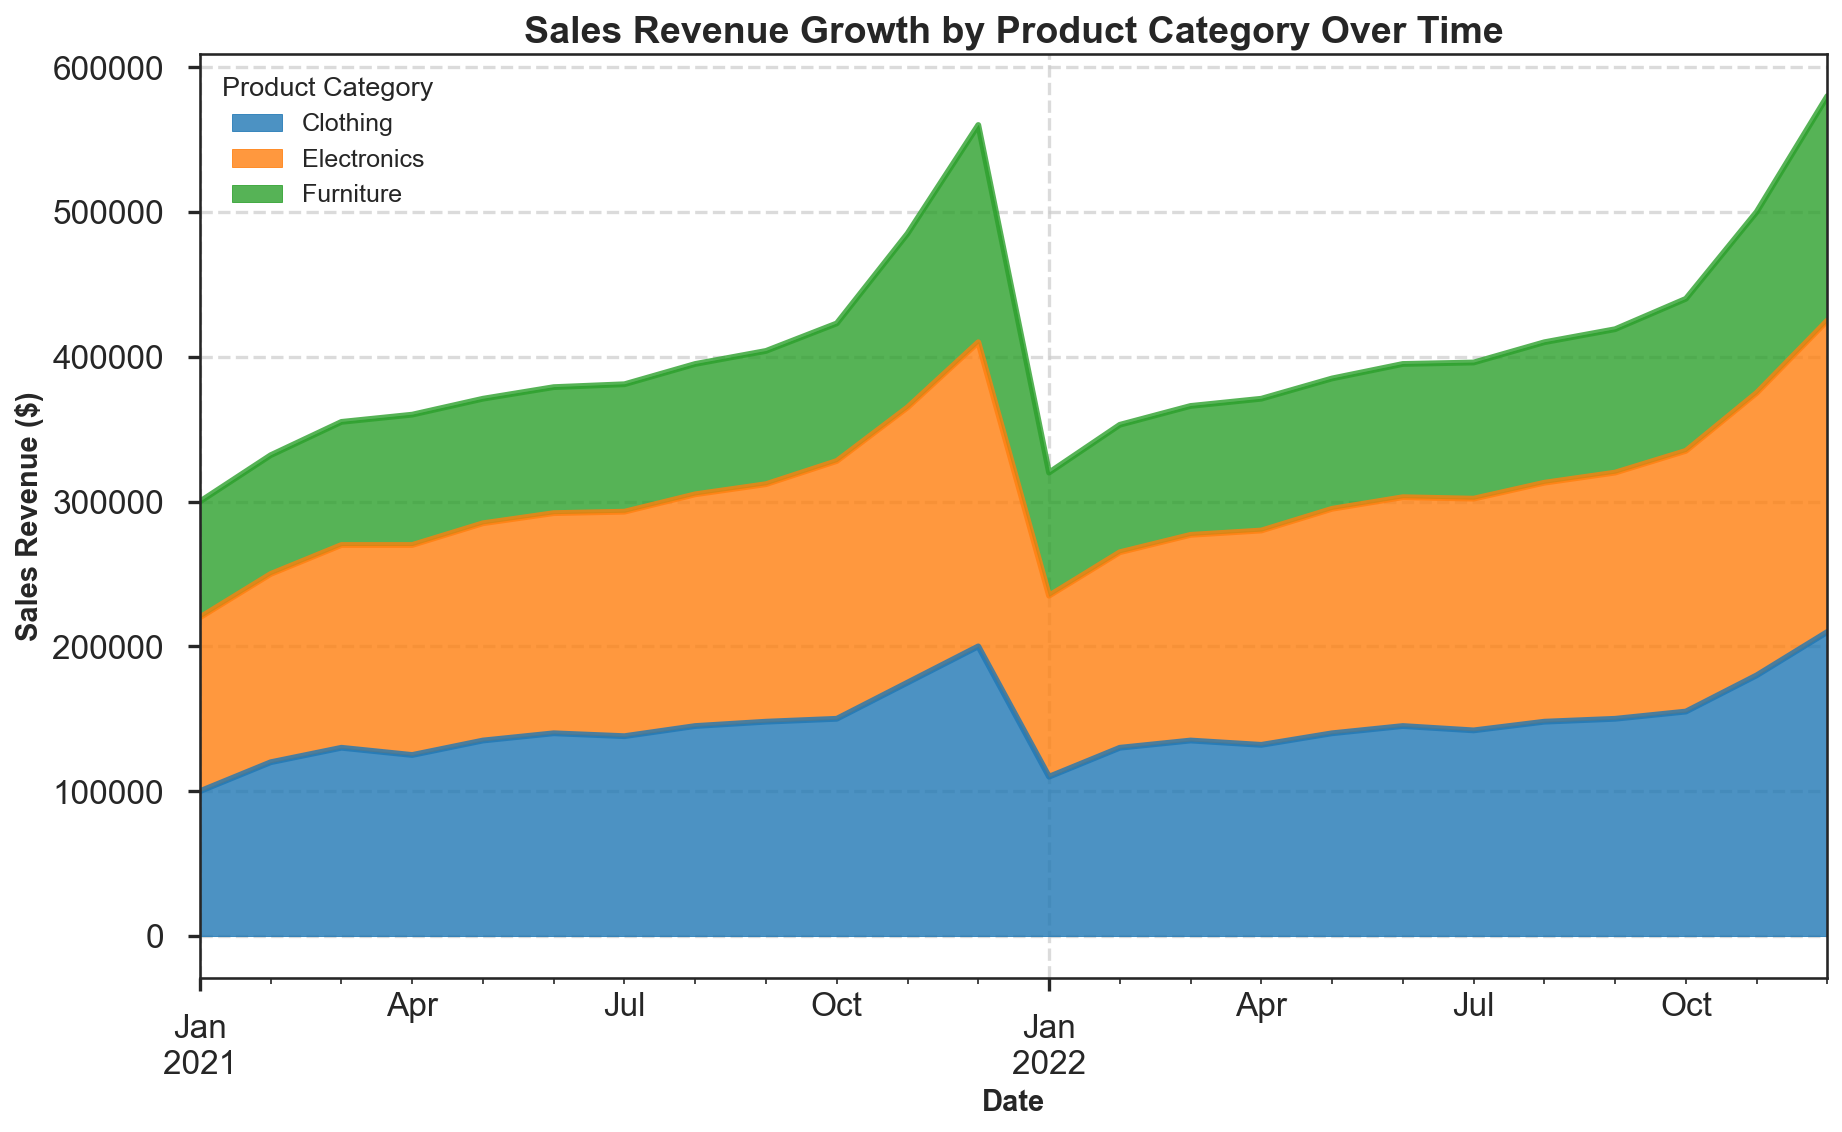Which product category showed the highest sales revenue in December 2022? By looking at the area corresponding to December 2022, we can see that the tallest section, representing the highest sales revenue, corresponds to the Electronics category.
Answer: Electronics Which season generally shows a spike in sales revenue for all product categories? Observing the area chart, we notice that there is a consistent spike across all categories during the month of November and December, indicating the holiday season as a period of increased sales.
Answer: Holiday Season (November and December) Comparing January 2021 and January 2022, which product category had the highest increase in sales revenue? By comparing the heights of the areas in January 2021 and January 2022 for each product category, we can see that Electronics had an increase from $120,000 to $125,000; Furniture increased from $80,000 to $85,000; and Clothing decreased from $100,000 to $110,000.
Answer: Clothing In which month did Electronics surpass a sales revenue of $200,000 for the first time? Observing the progression of the Electronics area, we find that in December 2021, the sales revenue for Electronics exceeded $200,000 for the first time.
Answer: December 2021 What was the sales revenue for Furniture in June 2021, and how does it compare to June 2022? To find the sales revenue for Furniture, we look at the height of the Furniture area in June 2021 and June 2022. In June 2021, the sales revenue was $87,000, while in June 2022, it was $92,000. This shows an increase from $87,000 to $92,000.
Answer: Increased Which product category saw the most consistent growth in sales revenue over the given time period? By visually inspecting the overall trends, Electronics showed the most consistent upward trajectory in its area, indicating steady growth in sales revenue throughout the time period.
Answer: Electronics Between Electronics and Clothing, which category had a higher sales revenue in October 2022? By comparing the height of the areas for Electronics and Clothing in October 2022, we can see that the Clothing section is higher, indicating a higher sales revenue.
Answer: Clothing Calculate the total sales revenue for Clothing in the year 2021. To calculate the total sales revenue for Clothing in 2021, sum the revenues for each month from January to December 2021: $100,000 + $120,000 + $130,000 + $125,000 + $135,000 + $140,000 + $138,000 + $145,000 + $148,000 + $150,000 + $175,000 + $200,000. The total is $1,706,000.
Answer: $1,706,000 During the peak month of sales revenue for Electronics in 2022, what was the corresponding sales revenue for Clothing? By noting the peak month for Electronics sales revenue in 2022, December, and looking at the corresponding height for Clothing, we find that the revenue for Clothing in December 2022 was $210,000.
Answer: $210,000 In November 2021, which product category contributed the least to sales revenue? By comparing the height of the areas for each category in November 2021, it is clear that Furniture had the shortest section, contributing the least to the sales revenue.
Answer: Furniture 